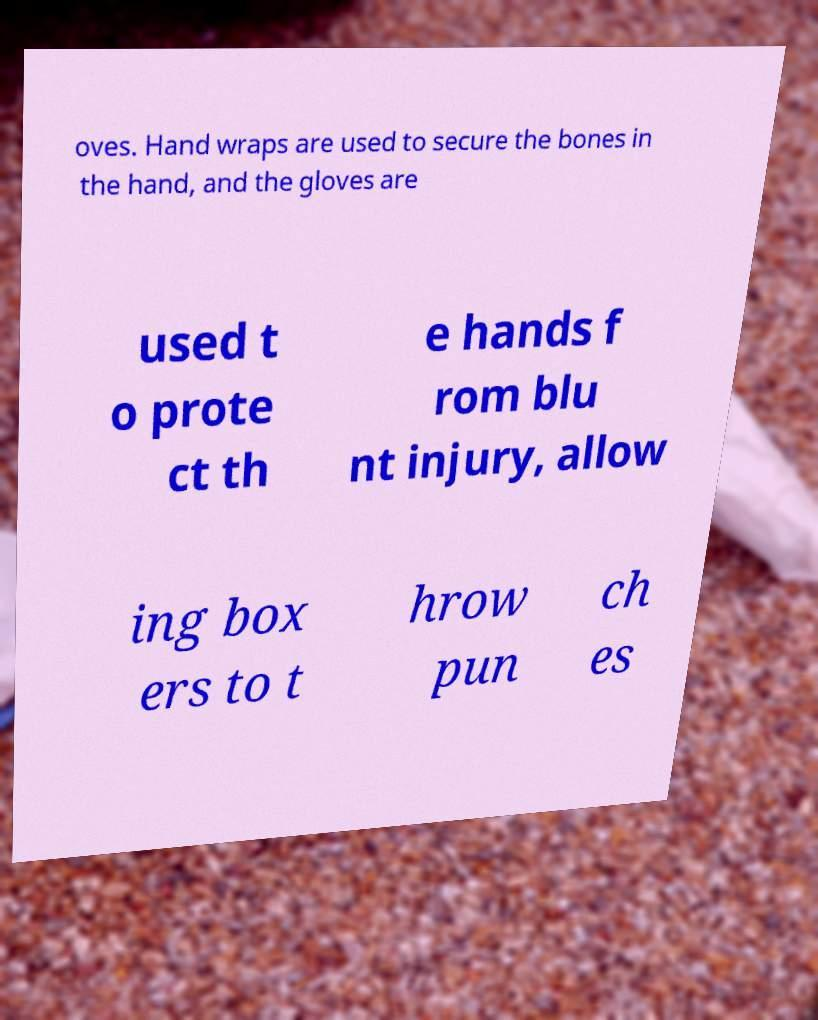Could you extract and type out the text from this image? oves. Hand wraps are used to secure the bones in the hand, and the gloves are used t o prote ct th e hands f rom blu nt injury, allow ing box ers to t hrow pun ch es 